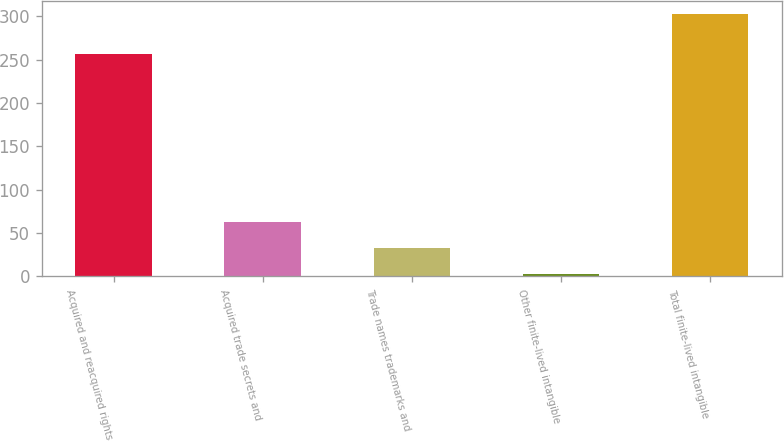Convert chart. <chart><loc_0><loc_0><loc_500><loc_500><bar_chart><fcel>Acquired and reacquired rights<fcel>Acquired trade secrets and<fcel>Trade names trademarks and<fcel>Other finite-lived intangible<fcel>Total finite-lived intangible<nl><fcel>256.1<fcel>63.06<fcel>33.13<fcel>3.2<fcel>302.5<nl></chart> 